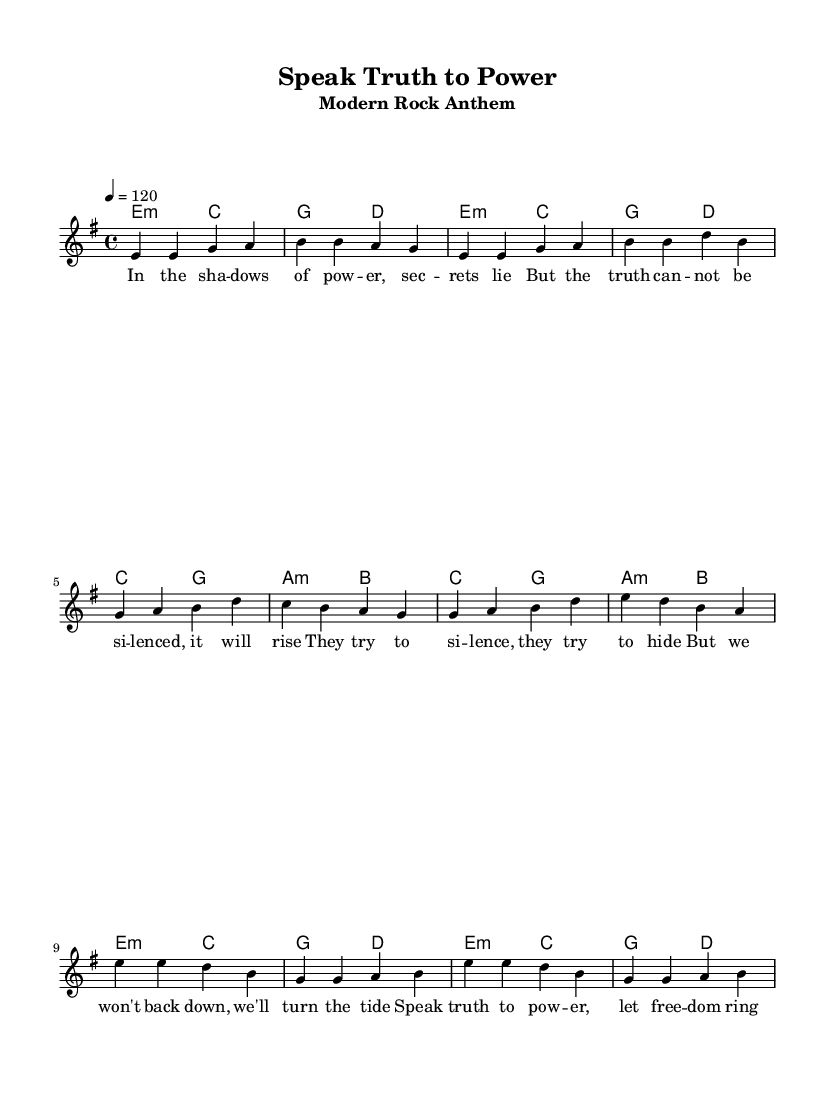What is the key signature of this music? The key signature is indicated at the beginning of the score. It's E minor, which has one sharp (F#).
Answer: E minor What is the time signature? The time signature is displayed at the start of the piece and is 4/4, indicating there are four beats per measure.
Answer: 4/4 What is the tempo marking? The tempo marking is provided at the start, showing a metronome marking of 120 beats per minute, suggesting a moderately fast tempo.
Answer: 120 How many measures are in the verse section? By counting the measures in the verse section, there are a total of 4 measures. Each grouping in the music corresponds to one measure.
Answer: 4 How many different chords are used in the chorus section? The chorus contains two distinct chords: E minor and G major, which can be identified in the chord symbols under the melody.
Answer: 2 What theme does the song address? The title and lyrics imply a theme about speaking out against oppression and protecting whistleblowers, particularly emphasizing freedom of speech and justice.
Answer: Whistleblower protection What is the last note of the chorus? The last note of the chorus, as shown in the melody, is a B note. This can be determined by looking at the final note of the melody line in the chorus section.
Answer: B 